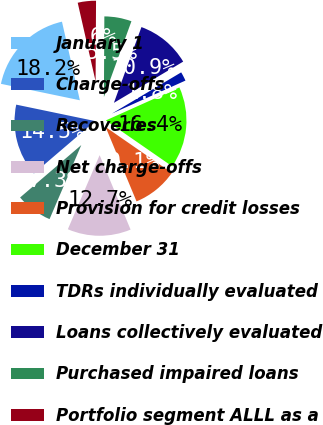<chart> <loc_0><loc_0><loc_500><loc_500><pie_chart><fcel>January 1<fcel>Charge-offs<fcel>Recoveries<fcel>Net charge-offs<fcel>Provision for credit losses<fcel>December 31<fcel>TDRs individually evaluated<fcel>Loans collectively evaluated<fcel>Purchased impaired loans<fcel>Portfolio segment ALLL as a<nl><fcel>18.17%<fcel>14.54%<fcel>7.28%<fcel>12.72%<fcel>9.09%<fcel>16.35%<fcel>1.83%<fcel>10.91%<fcel>5.46%<fcel>3.65%<nl></chart> 